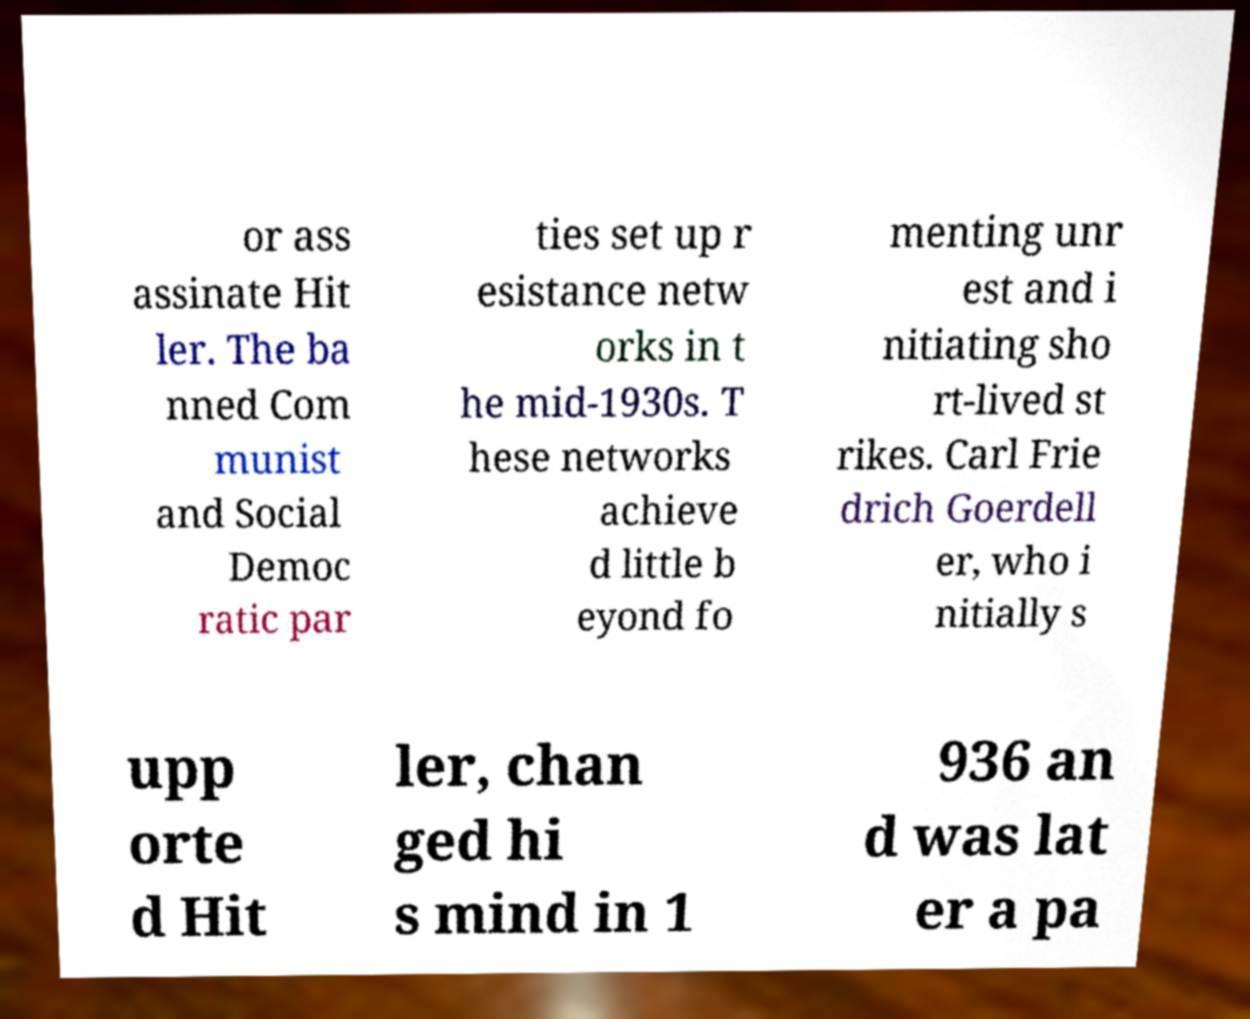Can you accurately transcribe the text from the provided image for me? or ass assinate Hit ler. The ba nned Com munist and Social Democ ratic par ties set up r esistance netw orks in t he mid-1930s. T hese networks achieve d little b eyond fo menting unr est and i nitiating sho rt-lived st rikes. Carl Frie drich Goerdell er, who i nitially s upp orte d Hit ler, chan ged hi s mind in 1 936 an d was lat er a pa 